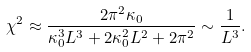<formula> <loc_0><loc_0><loc_500><loc_500>\chi ^ { 2 } \approx \frac { 2 \pi ^ { 2 } \kappa _ { 0 } } { \kappa _ { 0 } ^ { 3 } L ^ { 3 } + 2 \kappa _ { 0 } ^ { 2 } L ^ { 2 } + 2 \pi ^ { 2 } } \sim \frac { 1 } { L ^ { 3 } } .</formula> 